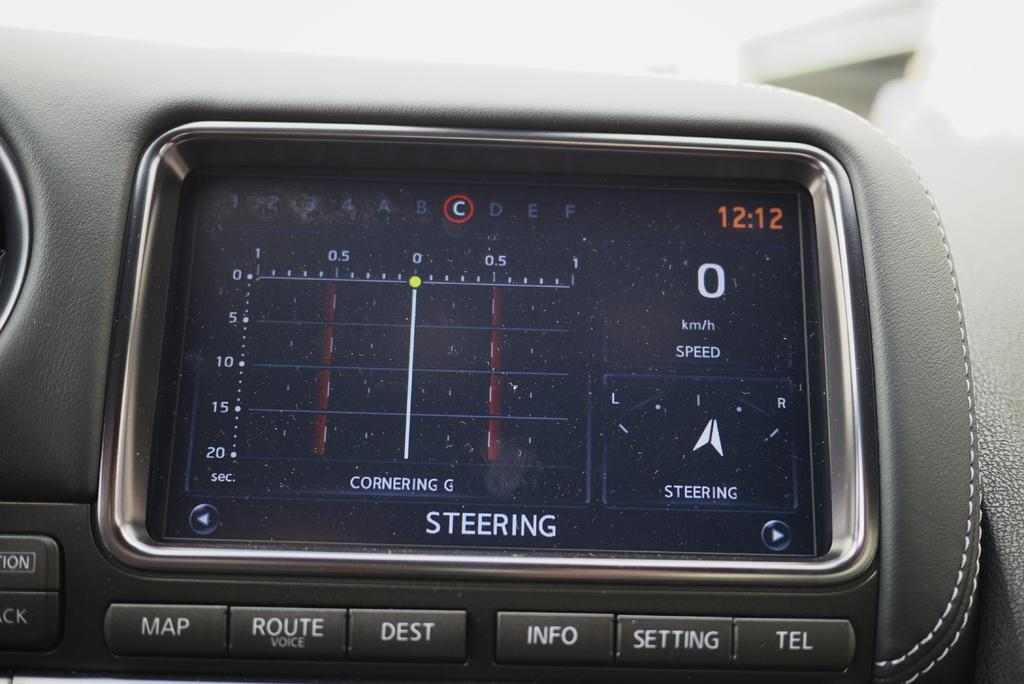Provide a one-sentence caption for the provided image. A steering device is built into a car dashboard showing the time and attributes related to current steering of the vehicle. 